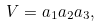<formula> <loc_0><loc_0><loc_500><loc_500>V = a _ { 1 } a _ { 2 } a _ { 3 } ,</formula> 